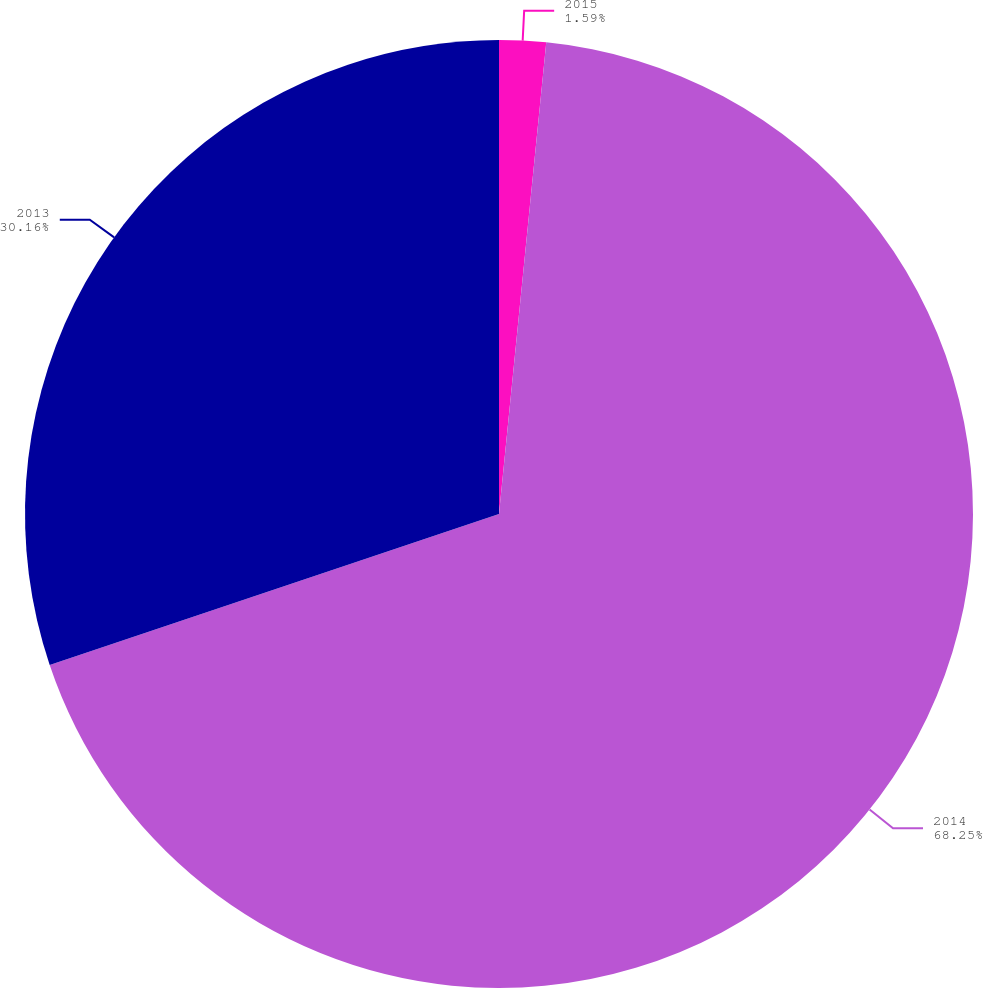Convert chart to OTSL. <chart><loc_0><loc_0><loc_500><loc_500><pie_chart><fcel>2015<fcel>2014<fcel>2013<nl><fcel>1.59%<fcel>68.25%<fcel>30.16%<nl></chart> 